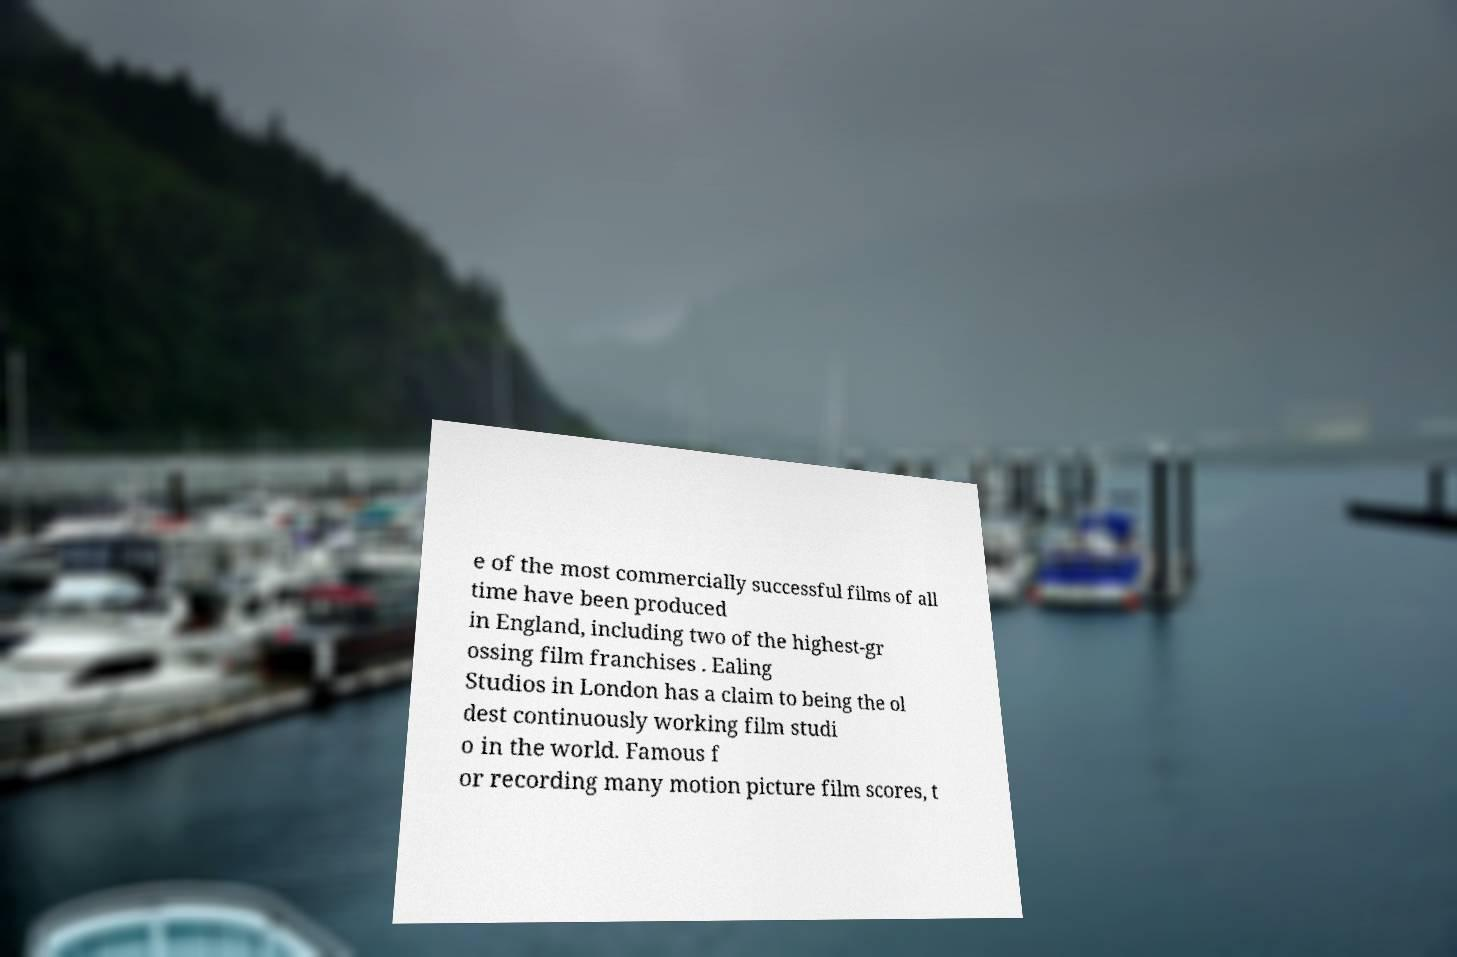I need the written content from this picture converted into text. Can you do that? e of the most commercially successful films of all time have been produced in England, including two of the highest-gr ossing film franchises . Ealing Studios in London has a claim to being the ol dest continuously working film studi o in the world. Famous f or recording many motion picture film scores, t 